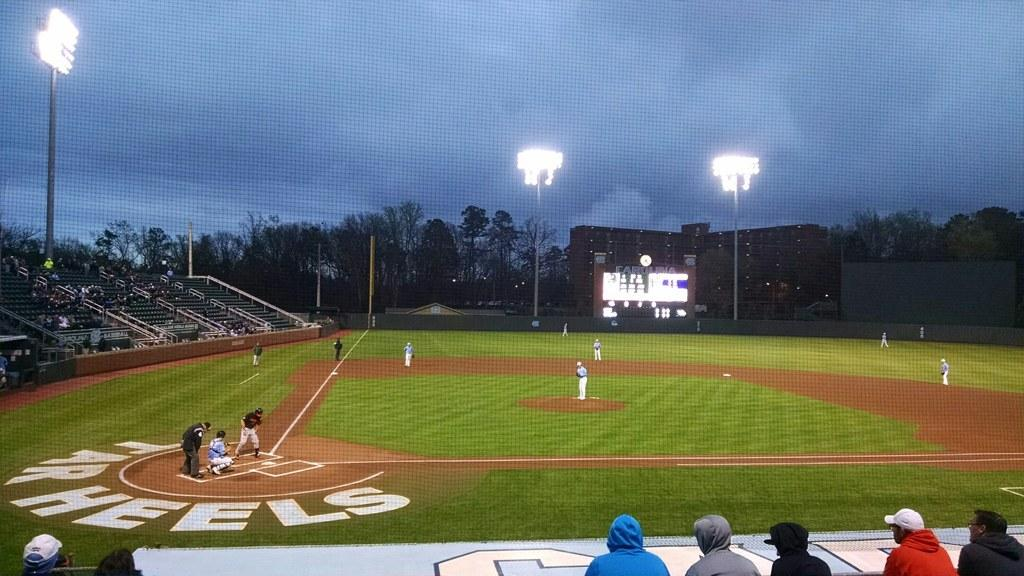<image>
Provide a brief description of the given image. A view of the Tar Heels baseball field during a game. 